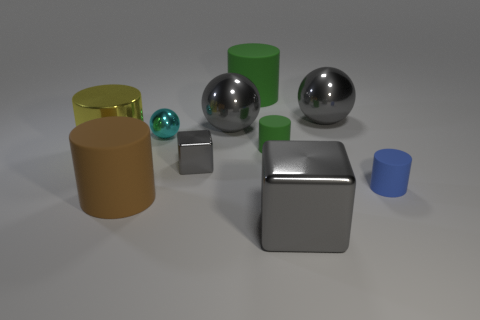What color is the other big shiny thing that is the same shape as the brown object?
Make the answer very short. Yellow. Is there any other thing of the same color as the metal cylinder?
Provide a short and direct response. No. What number of metallic objects are either small cyan balls or gray objects?
Give a very brief answer. 5. Do the small block and the large shiny block have the same color?
Make the answer very short. Yes. Are there more metal blocks on the left side of the tiny gray metallic block than large gray metal objects?
Give a very brief answer. No. How many other things are there of the same material as the brown object?
Ensure brevity in your answer.  3. How many big things are purple metallic balls or brown rubber cylinders?
Keep it short and to the point. 1. Do the tiny cyan object and the tiny blue thing have the same material?
Give a very brief answer. No. There is a large yellow metallic thing that is to the left of the tiny metallic block; how many tiny things are behind it?
Offer a terse response. 2. Are there any green objects that have the same shape as the large yellow thing?
Keep it short and to the point. Yes. 